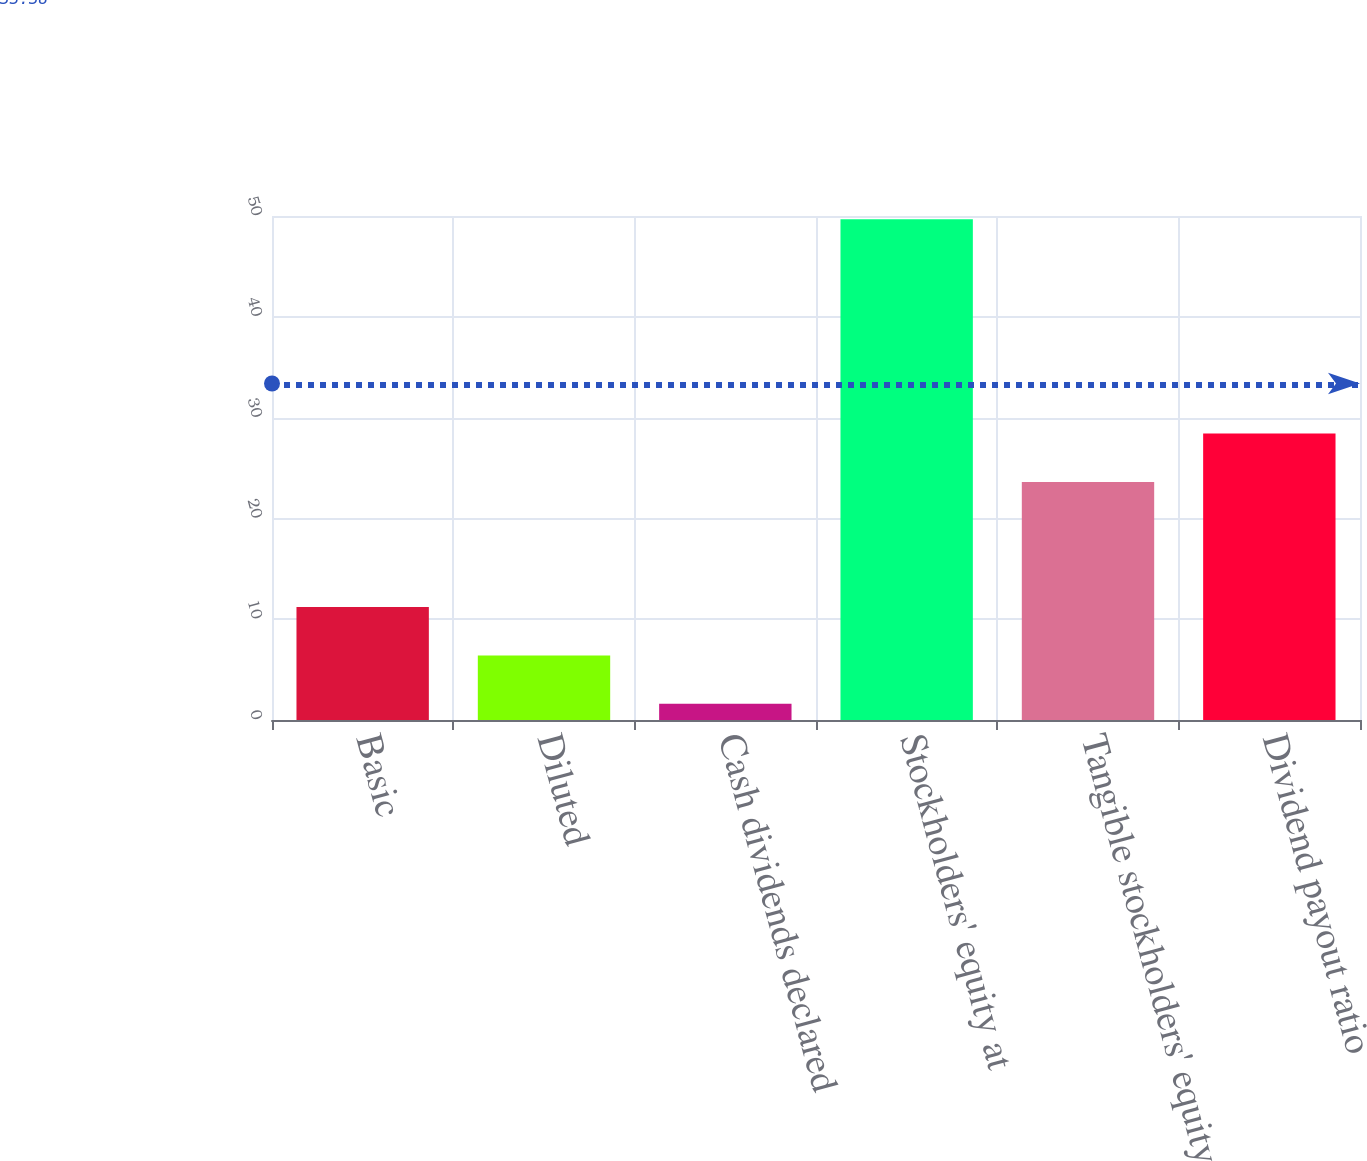<chart> <loc_0><loc_0><loc_500><loc_500><bar_chart><fcel>Basic<fcel>Diluted<fcel>Cash dividends declared<fcel>Stockholders' equity at<fcel>Tangible stockholders' equity<fcel>Dividend payout ratio<nl><fcel>11.22<fcel>6.41<fcel>1.6<fcel>49.68<fcel>23.62<fcel>28.43<nl></chart> 